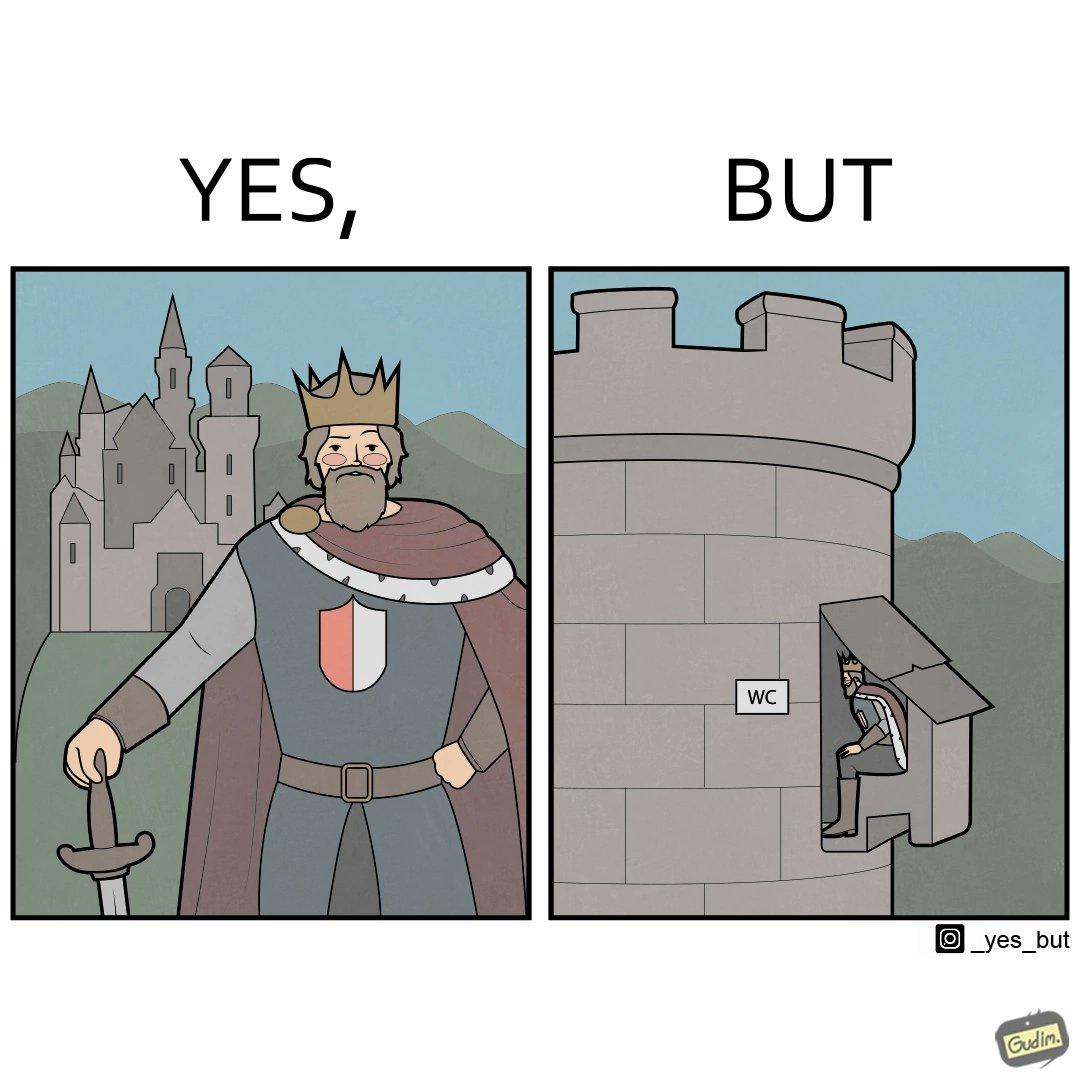Does this image contain satire or humor? Yes, this image is satirical. 